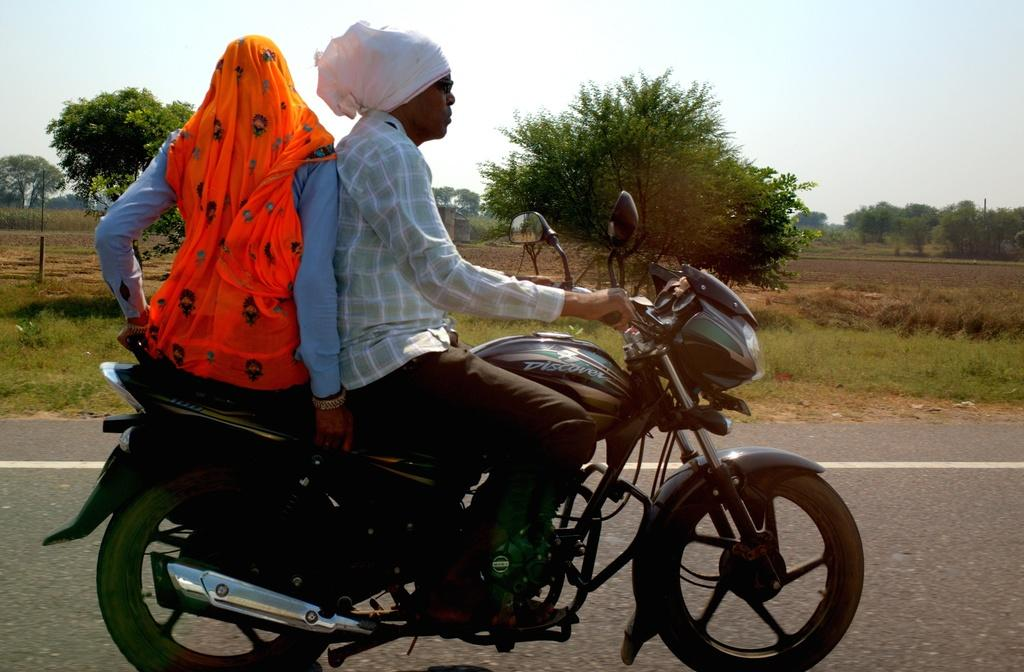How many people are in the image? There is a man and a woman in the image. What are the man and woman doing in the image? The man and woman are traveling on a bike. What type of terrain can be seen in the image? There is grass visible in the image. What other natural elements can be seen in the image? There are trees and the sky visible in the image. What is the reaction of the sand to the bike in the image? There is no sand present in the image, so it is not possible to determine the reaction of sand to the bike. 